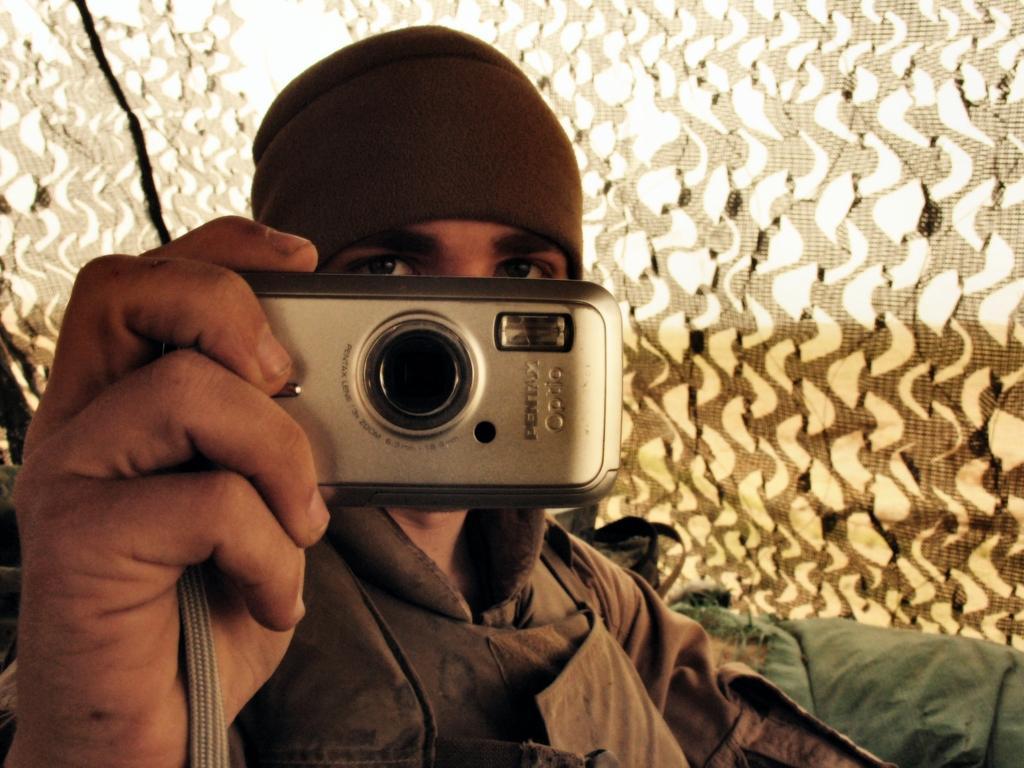Please provide a concise description of this image. In this image I can see person is holding camera. He is wearing brown color coat. We can see green color cloth and background is in white and brown color. 